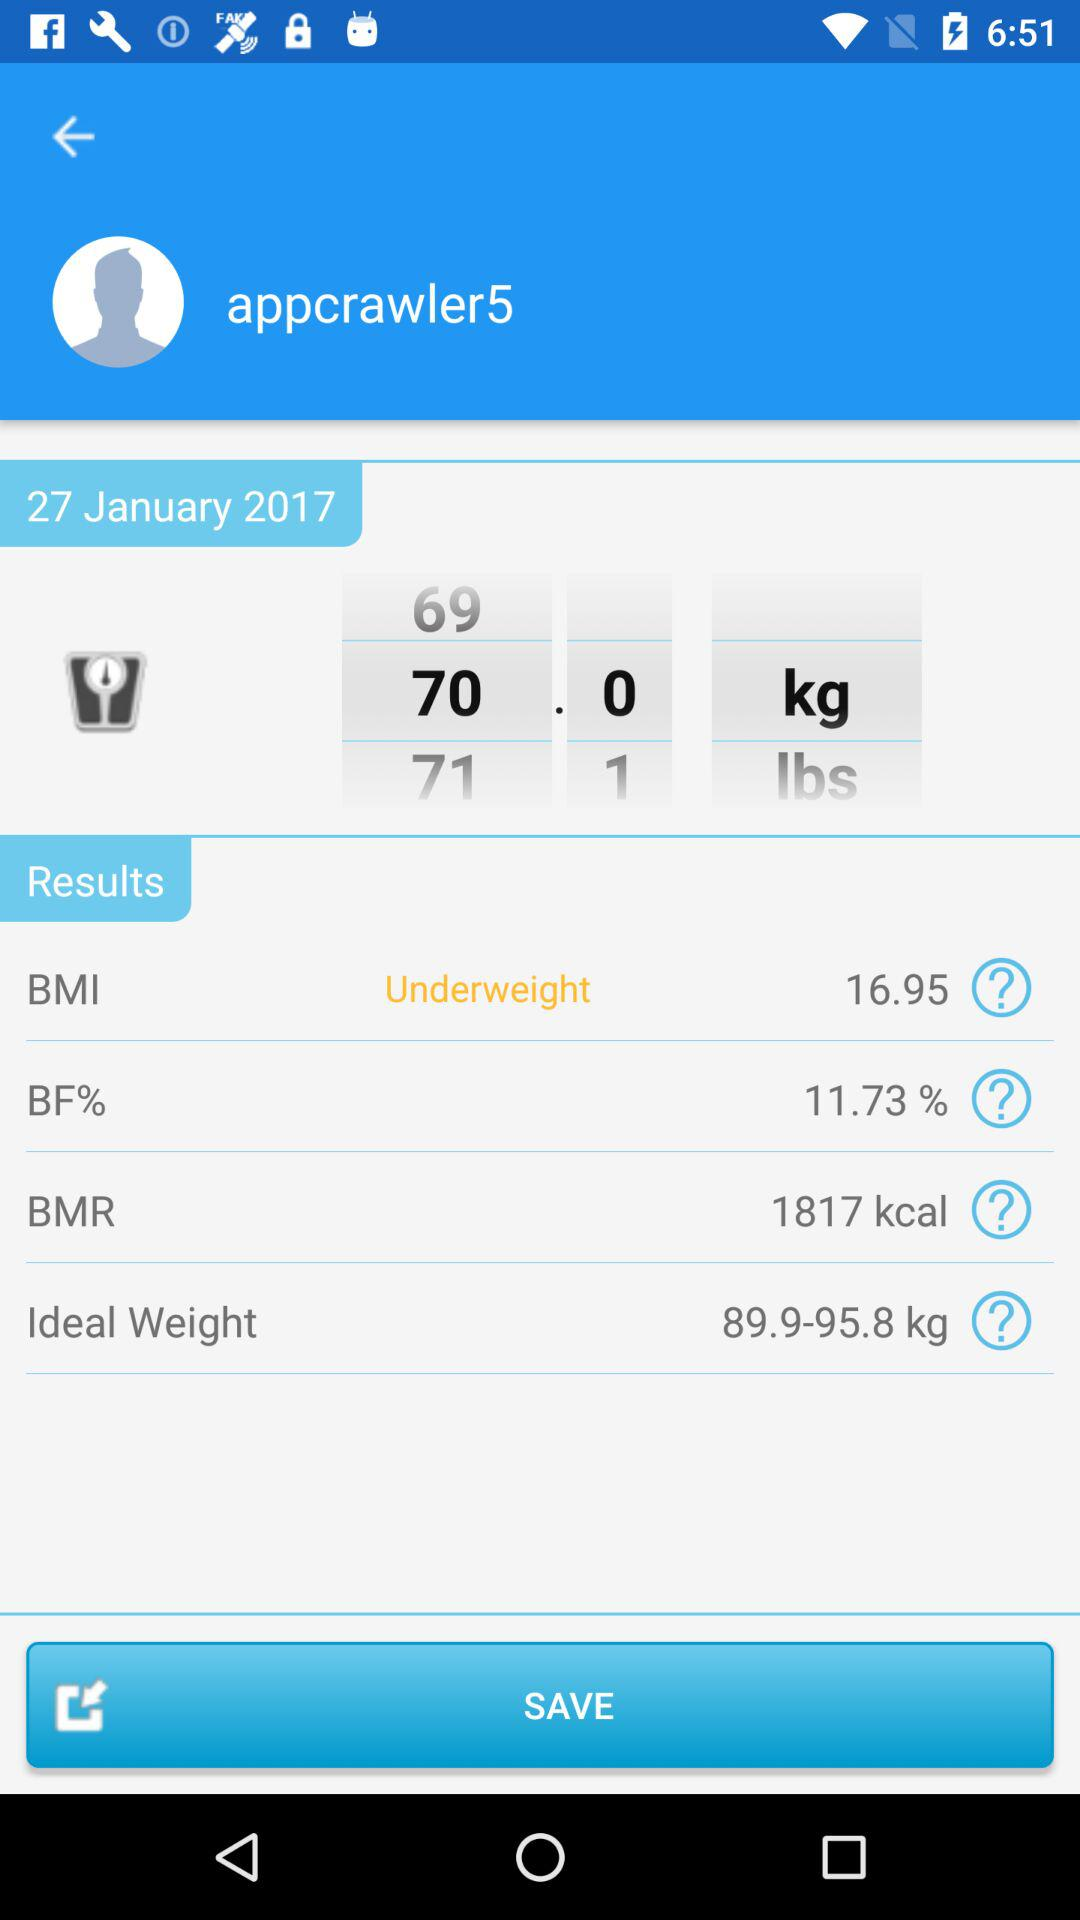What is the selected weight for 27 January? The selected weight is 70.0 kg. 